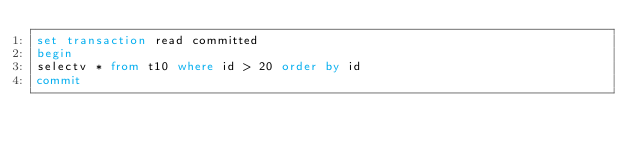<code> <loc_0><loc_0><loc_500><loc_500><_SQL_>set transaction read committed
begin
selectv * from t10 where id > 20 order by id
commit
</code> 